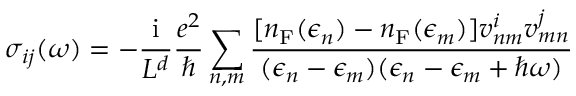Convert formula to latex. <formula><loc_0><loc_0><loc_500><loc_500>\sigma _ { i j } ( \omega ) = - \frac { i } { L ^ { d } } \frac { e ^ { 2 } } { } \sum _ { n , m } \frac { [ n _ { F } ( \epsilon _ { n } ) - n _ { F } ( \epsilon _ { m } ) ] v _ { n m } ^ { i } v _ { m n } ^ { j } } { ( \epsilon _ { n } - \epsilon _ { m } ) ( \epsilon _ { n } - \epsilon _ { m } + \hbar { \omega } ) }</formula> 